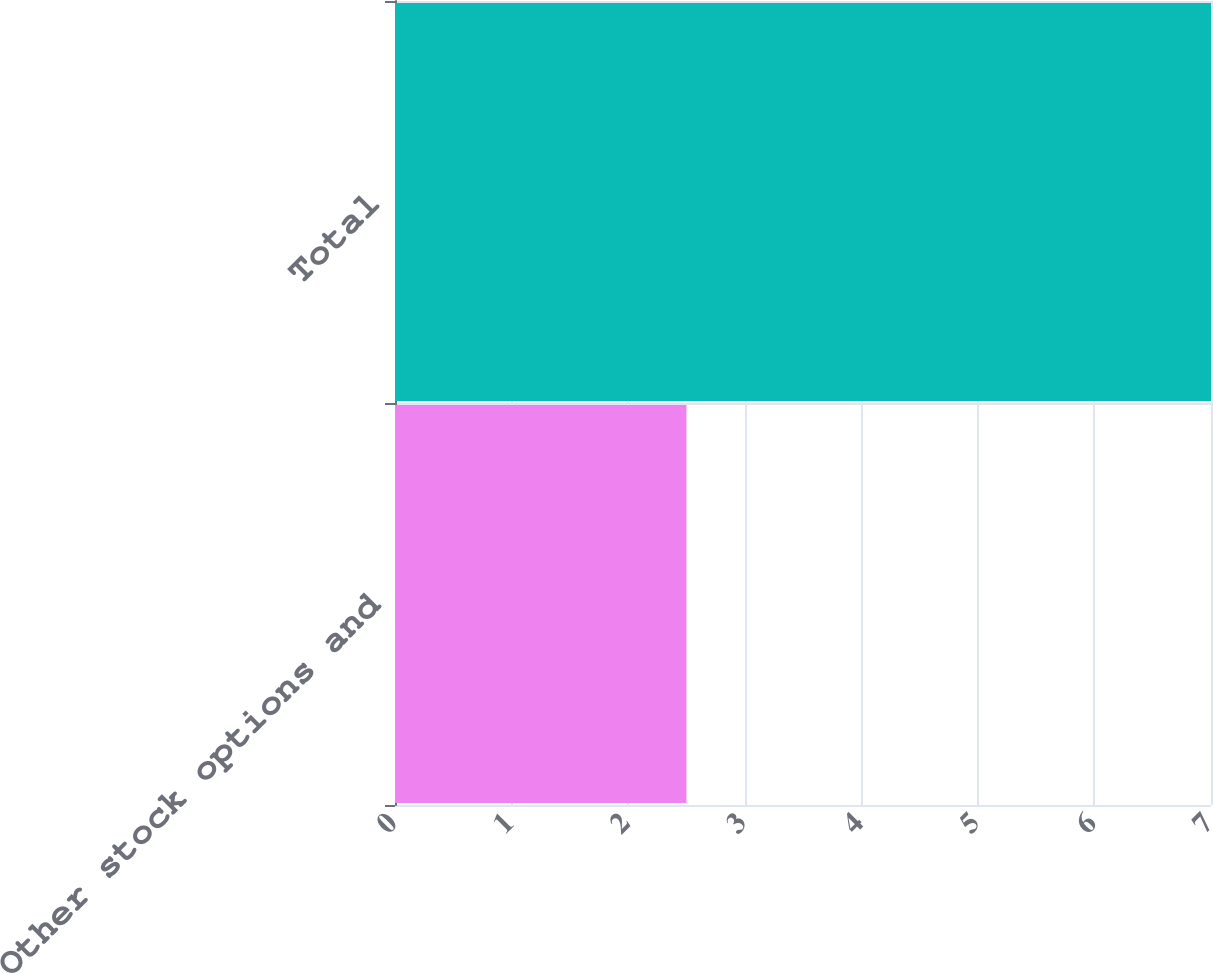Convert chart to OTSL. <chart><loc_0><loc_0><loc_500><loc_500><bar_chart><fcel>Other stock options and<fcel>Total<nl><fcel>2.5<fcel>7<nl></chart> 